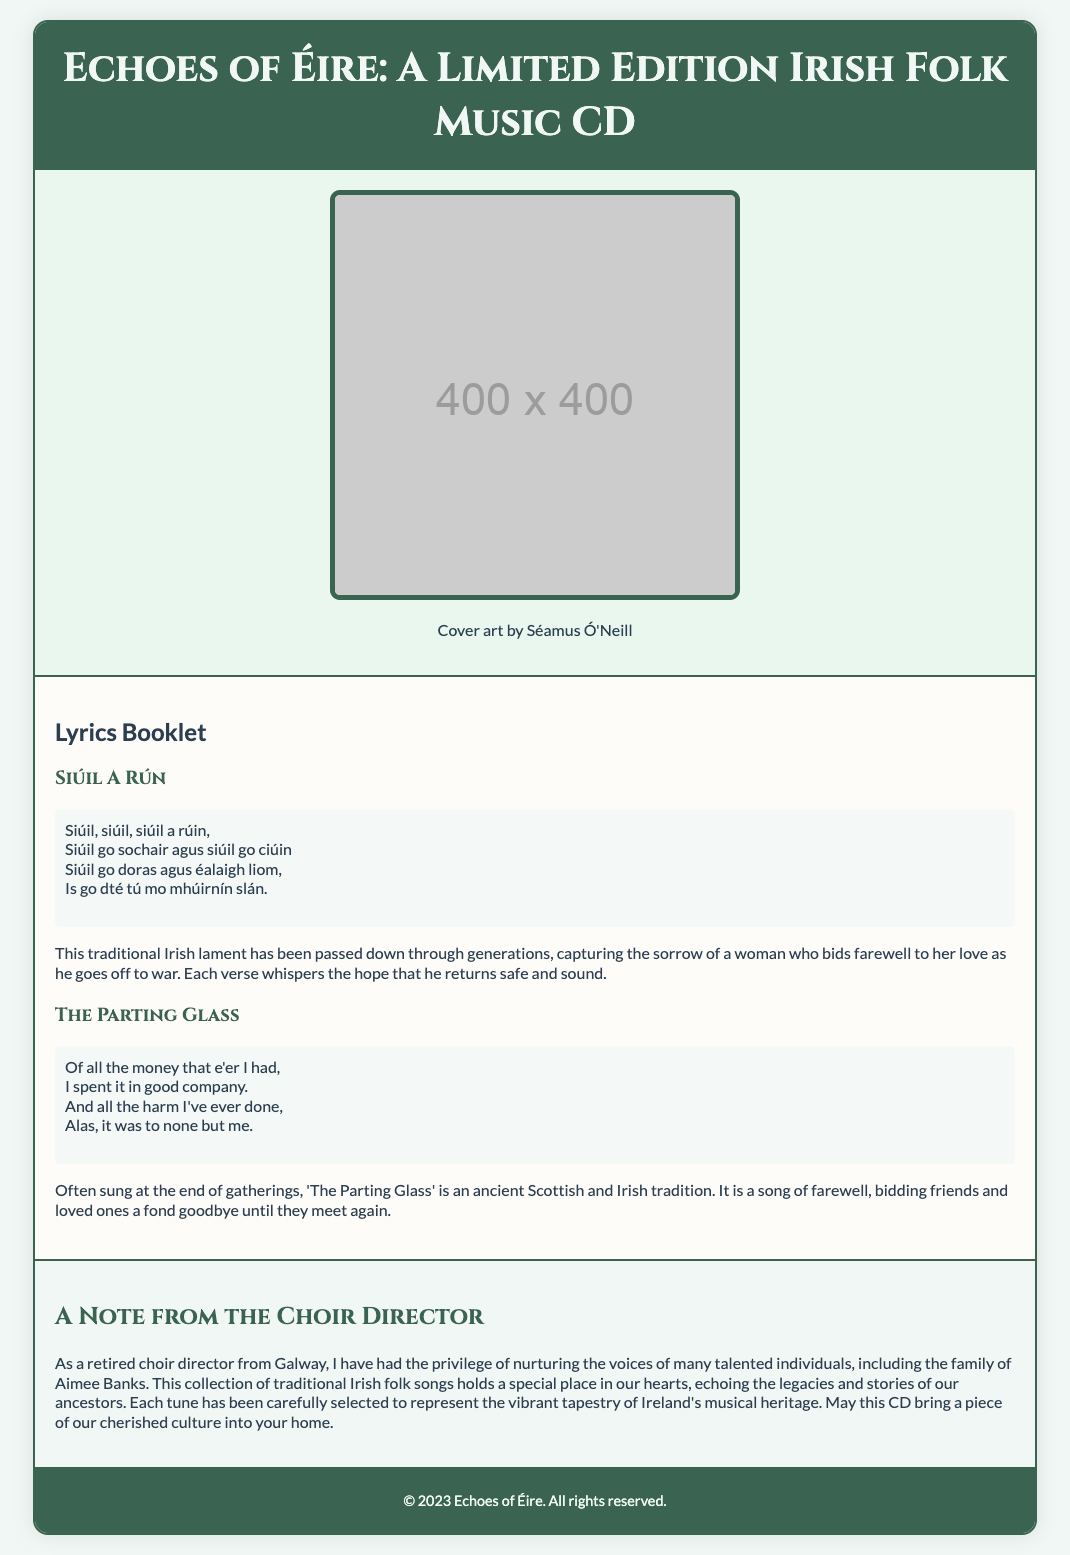What is the title of the CD? The title of the CD is prominently displayed in the header section of the document.
Answer: Echoes of Éire: A Limited Edition Irish Folk Music CD Who created the cover art? The cover art credit is provided in the cover art section of the document.
Answer: Séamus Ó'Neill What is the first song listed in the lyrics booklet? The first song title is the first one mentioned in the lyrics booklet section.
Answer: Siúil A Rún What type of music does the CD feature? The document indicates the genre of the music included in the CD.
Answer: Irish Folk Music How many songs are included in the lyrics booklet? The document contains two songs listed in the lyrics booklet section.
Answer: Two What is the main theme of 'The Parting Glass'? The explanation provided after the song showcases its significance and meaning.
Answer: Farewell What is the relationship of the choir director to Aimee Banks? The note from the choir director mentions a personal connection to Aimee Banks' family.
Answer: Personal acquaintance What significance does the choir director attribute to the songs? The choir director shares sentiments about the cultural importance of the songs selected for the CD.
Answer: Vibrant tapestry of Ireland's musical heritage 